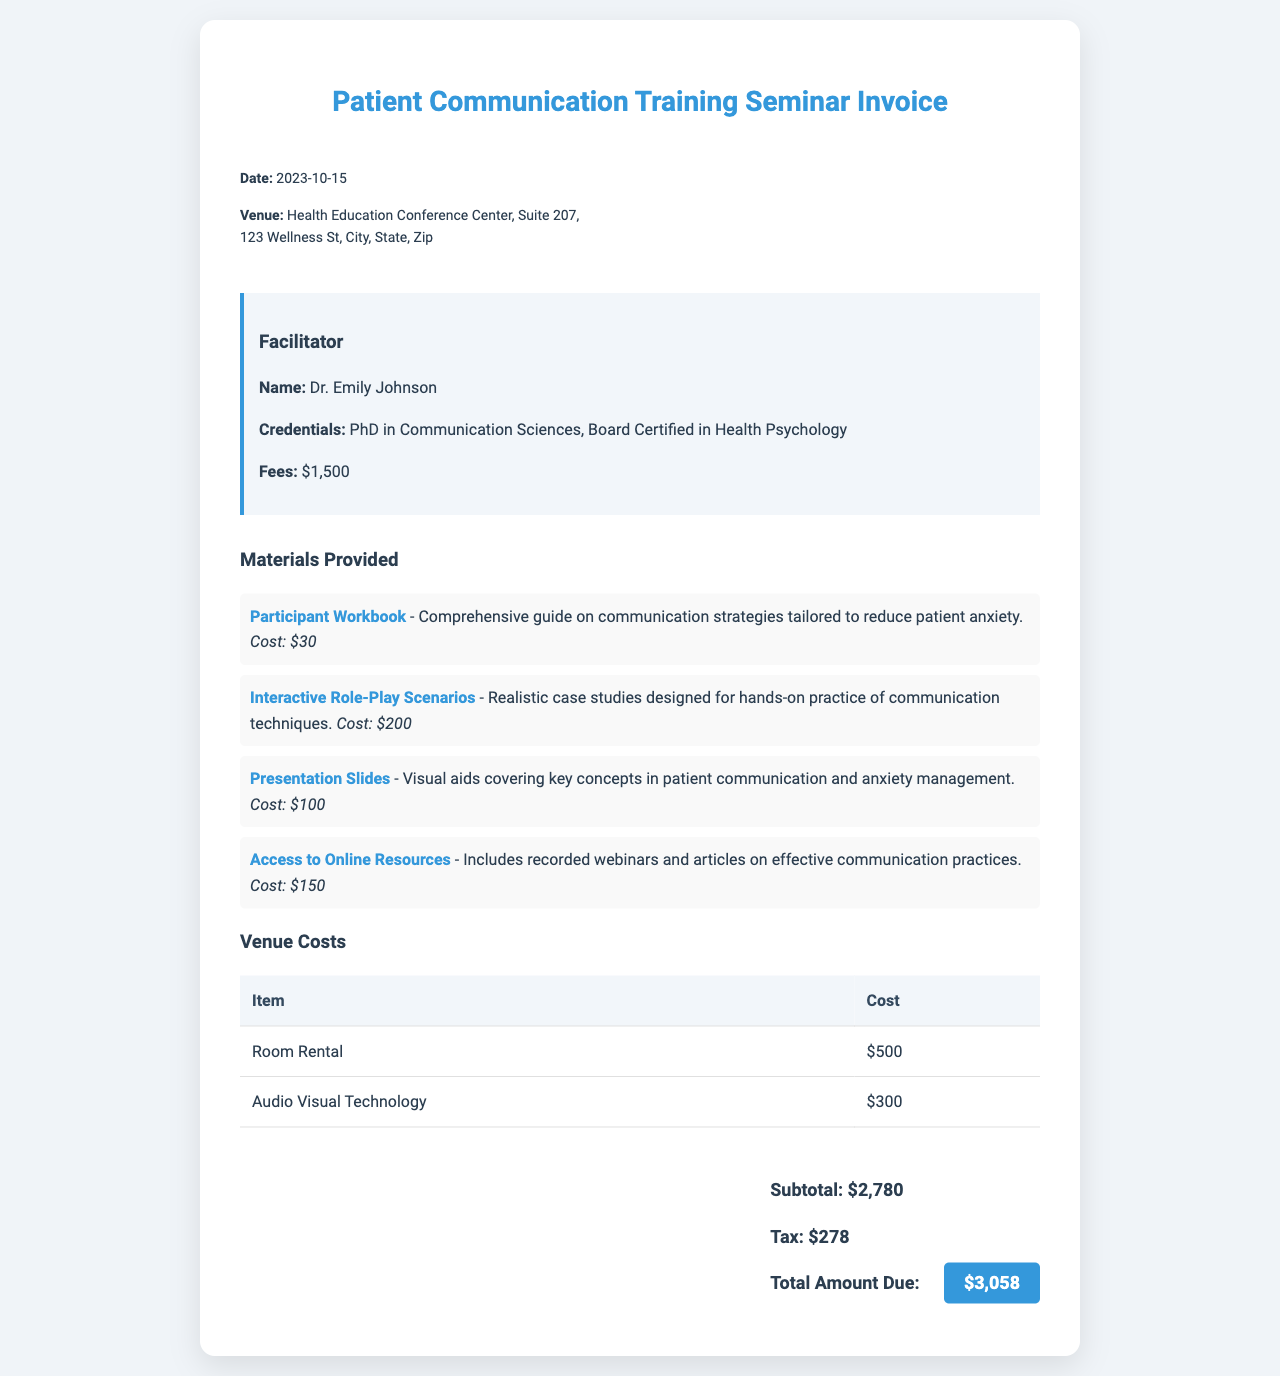What is the date of the seminar? The date of the seminar is provided in the document's header and is mentioned as "2023-10-15".
Answer: 2023-10-15 Who is the facilitator of the seminar? The invoice lists the facilitator's name, which is "Dr. Emily Johnson".
Answer: Dr. Emily Johnson What is the total amount due? The total amount due is clearly stated in the total section of the invoice as "$3,058".
Answer: $3,058 What is the cost of the Participant Workbook? The document specifies that the cost of the Participant Workbook is "$30".
Answer: $30 How much is the room rental for the venue? The document mentions the room rental cost in the venue costs section, which is "$500".
Answer: $500 What credentials does the facilitator have? The credentials of the facilitator include "PhD in Communication Sciences, Board Certified in Health Psychology".
Answer: PhD in Communication Sciences, Board Certified in Health Psychology What percentage does the tax amount represent of the subtotal? The tax amount is "$278" and the subtotal is "$2,780", which indicates a tax rate of 10%.
Answer: 10% What is the cost of the Audio Visual Technology? The cost for the Audio Visual Technology is stated as "$300".
Answer: $300 What resource is included for access to online materials? The document states "Access to Online Resources" as one of the materials provided.
Answer: Access to Online Resources 